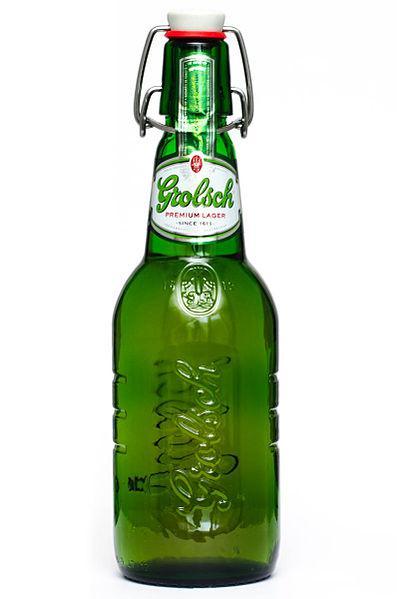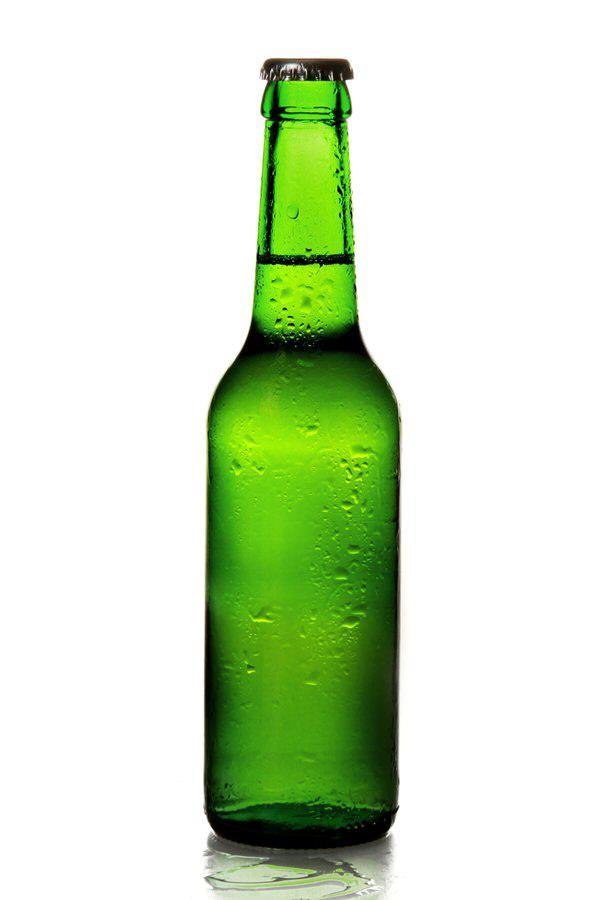The first image is the image on the left, the second image is the image on the right. For the images shown, is this caption "there are six bottles" true? Answer yes or no. No. The first image is the image on the left, the second image is the image on the right. Given the left and right images, does the statement "Three identical green bottles are standing in a row." hold true? Answer yes or no. No. 